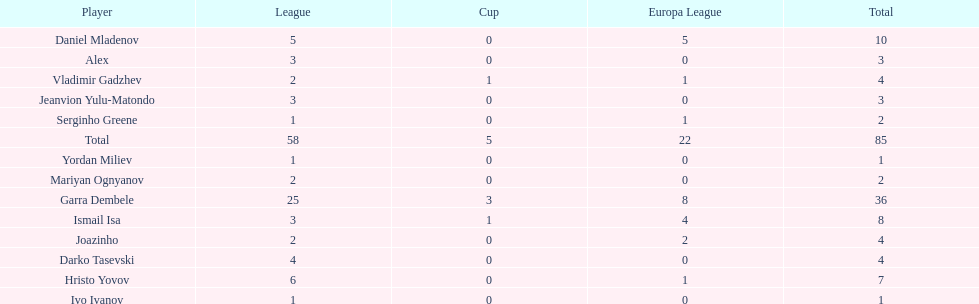What number of players in the cup didn't manage to score any goals? 10. 